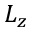Convert formula to latex. <formula><loc_0><loc_0><loc_500><loc_500>L _ { z }</formula> 